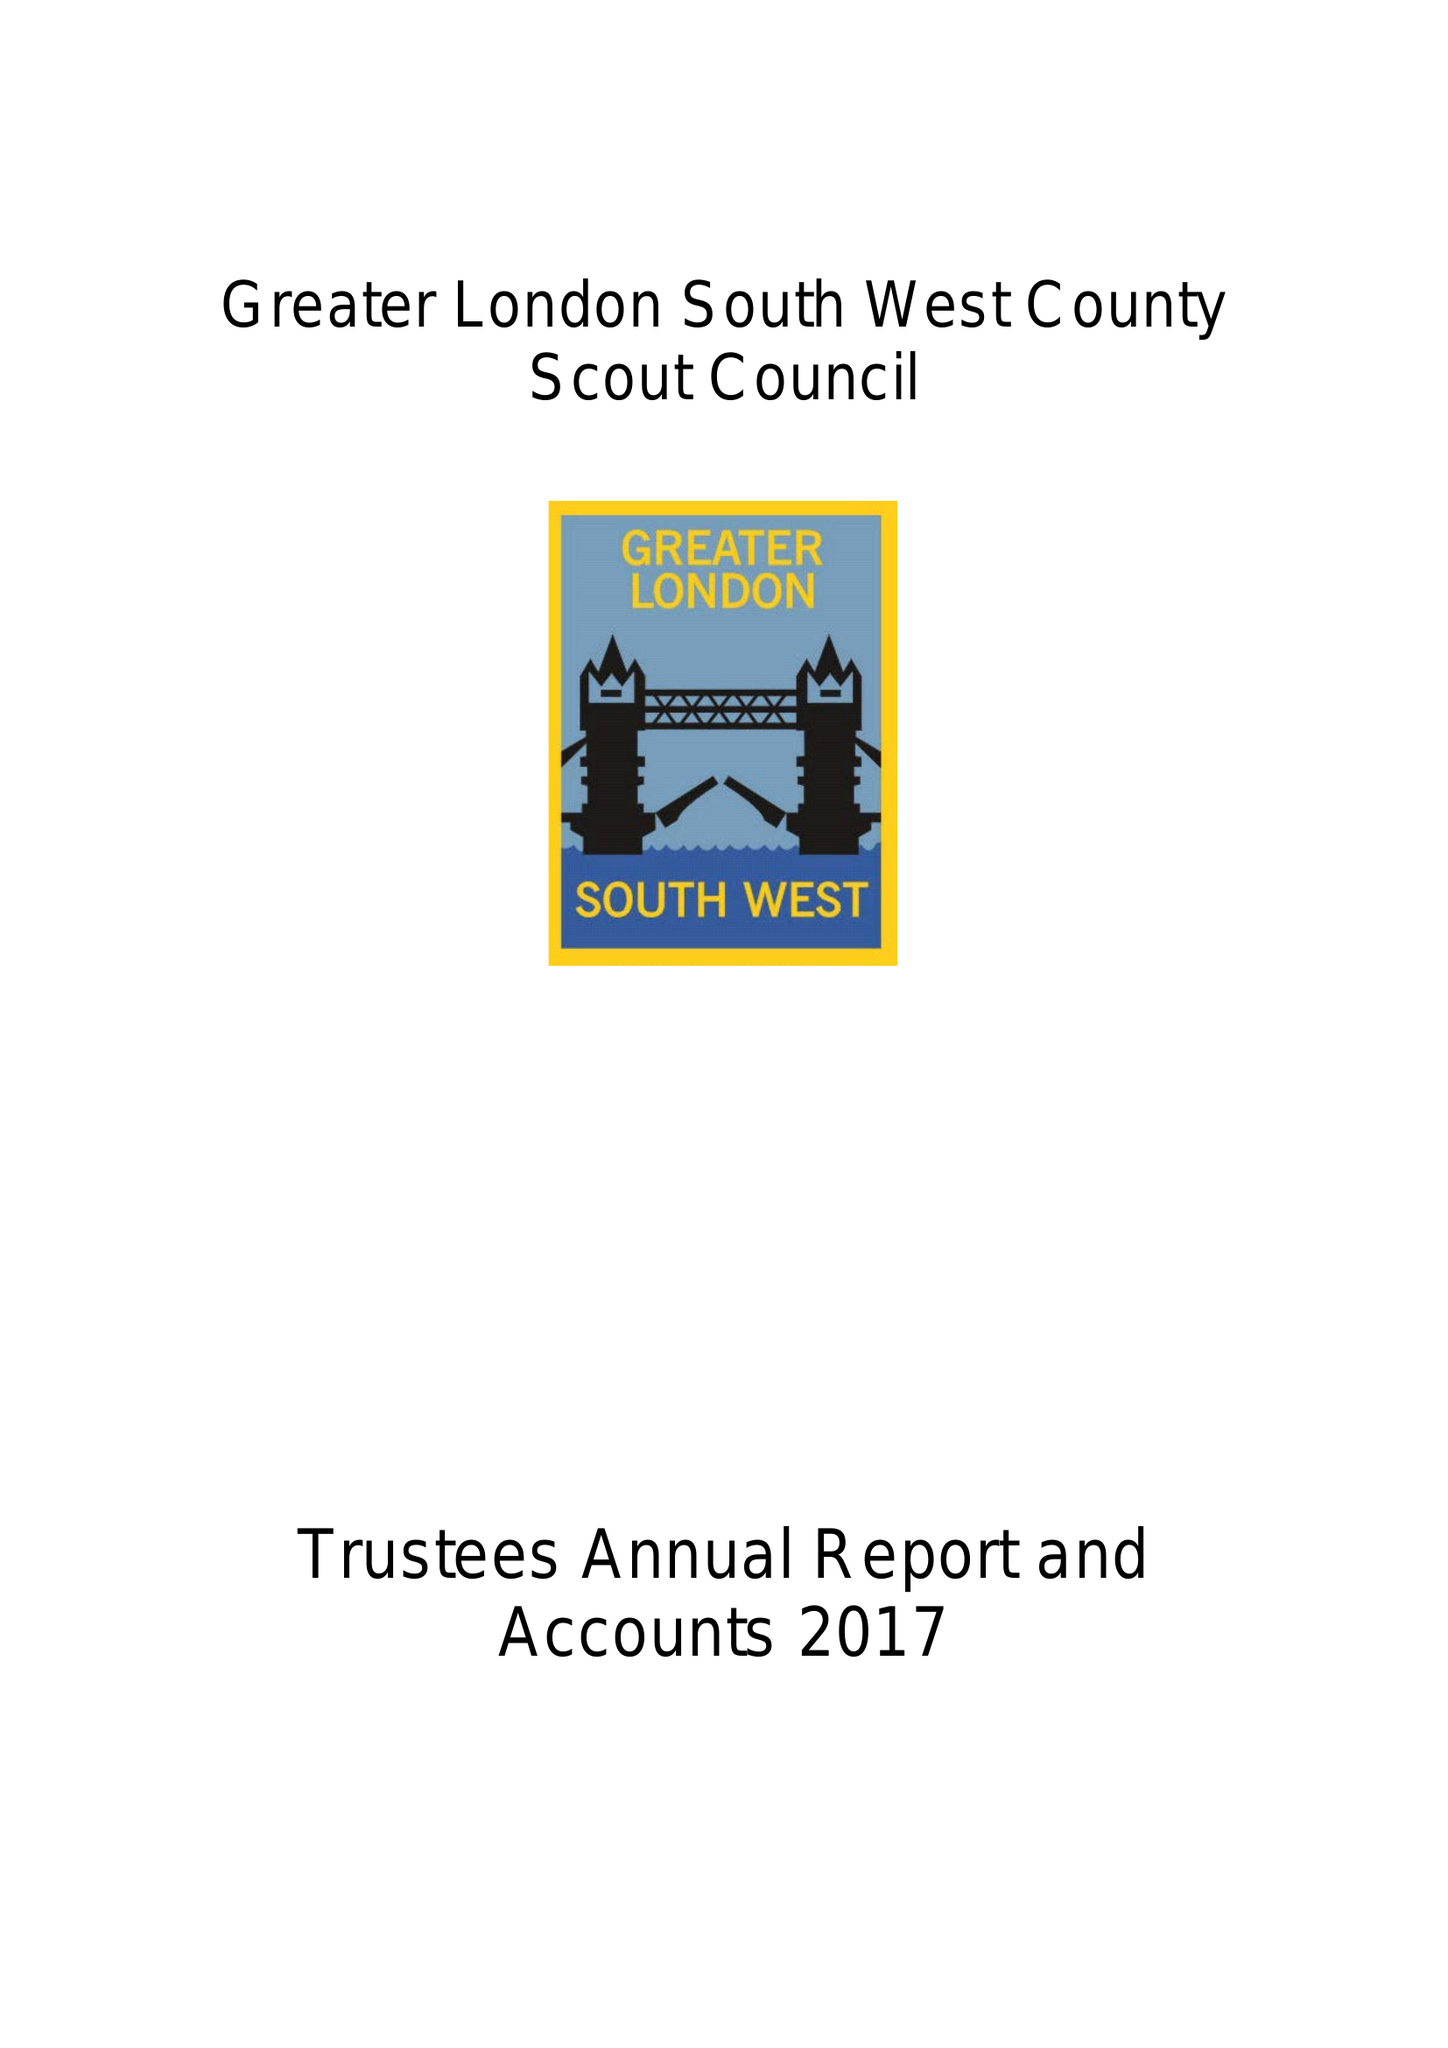What is the value for the address__street_line?
Answer the question using a single word or phrase. 42 THE MOUNT 